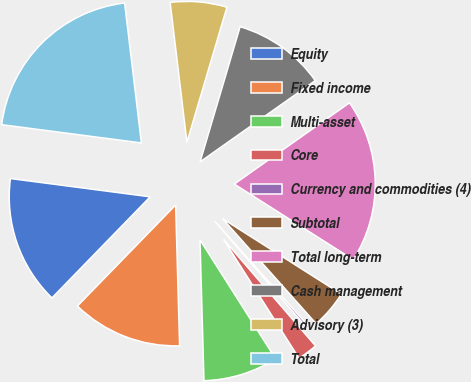Convert chart to OTSL. <chart><loc_0><loc_0><loc_500><loc_500><pie_chart><fcel>Equity<fcel>Fixed income<fcel>Multi-asset<fcel>Core<fcel>Currency and commodities (4)<fcel>Subtotal<fcel>Total long-term<fcel>Cash management<fcel>Advisory (3)<fcel>Total<nl><fcel>14.8%<fcel>12.72%<fcel>8.56%<fcel>2.33%<fcel>0.25%<fcel>4.4%<fcel>18.79%<fcel>10.64%<fcel>6.48%<fcel>21.03%<nl></chart> 